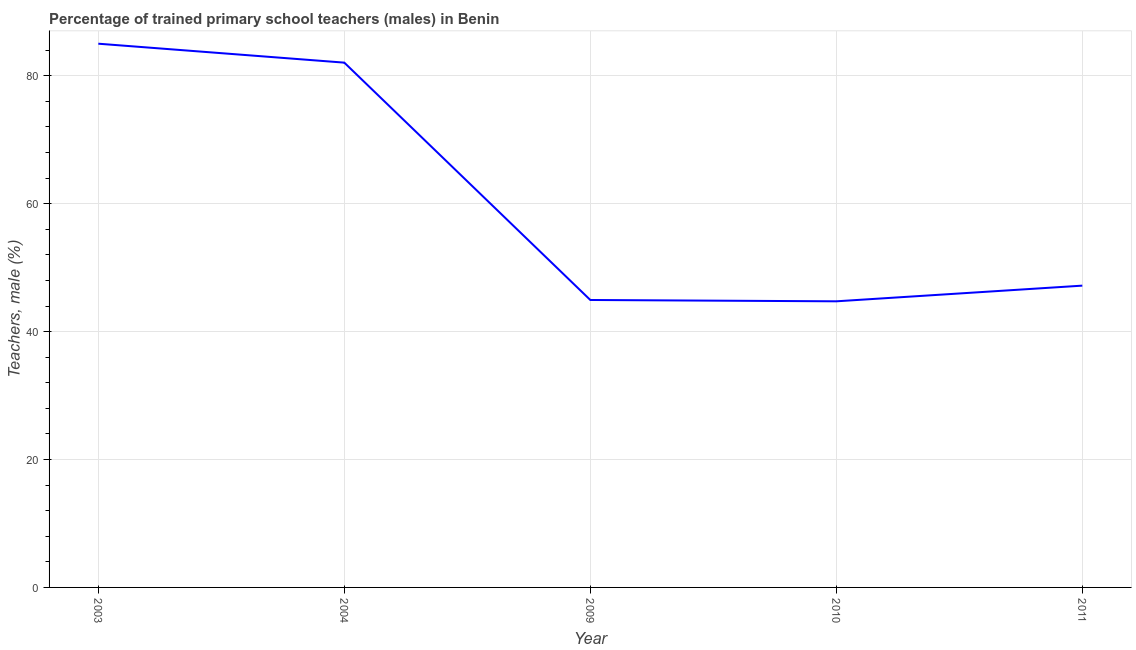What is the percentage of trained male teachers in 2011?
Keep it short and to the point. 47.19. Across all years, what is the maximum percentage of trained male teachers?
Make the answer very short. 85.01. Across all years, what is the minimum percentage of trained male teachers?
Your response must be concise. 44.74. In which year was the percentage of trained male teachers maximum?
Keep it short and to the point. 2003. In which year was the percentage of trained male teachers minimum?
Make the answer very short. 2010. What is the sum of the percentage of trained male teachers?
Ensure brevity in your answer.  303.93. What is the difference between the percentage of trained male teachers in 2004 and 2011?
Keep it short and to the point. 34.87. What is the average percentage of trained male teachers per year?
Offer a terse response. 60.79. What is the median percentage of trained male teachers?
Provide a succinct answer. 47.19. What is the ratio of the percentage of trained male teachers in 2010 to that in 2011?
Your answer should be compact. 0.95. What is the difference between the highest and the second highest percentage of trained male teachers?
Provide a short and direct response. 2.96. What is the difference between the highest and the lowest percentage of trained male teachers?
Provide a succinct answer. 40.28. In how many years, is the percentage of trained male teachers greater than the average percentage of trained male teachers taken over all years?
Offer a terse response. 2. How many lines are there?
Offer a terse response. 1. How many years are there in the graph?
Provide a succinct answer. 5. What is the difference between two consecutive major ticks on the Y-axis?
Provide a succinct answer. 20. Does the graph contain any zero values?
Make the answer very short. No. What is the title of the graph?
Your answer should be very brief. Percentage of trained primary school teachers (males) in Benin. What is the label or title of the X-axis?
Your response must be concise. Year. What is the label or title of the Y-axis?
Keep it short and to the point. Teachers, male (%). What is the Teachers, male (%) in 2003?
Provide a short and direct response. 85.01. What is the Teachers, male (%) in 2004?
Make the answer very short. 82.05. What is the Teachers, male (%) in 2009?
Your response must be concise. 44.94. What is the Teachers, male (%) in 2010?
Offer a very short reply. 44.74. What is the Teachers, male (%) in 2011?
Offer a very short reply. 47.19. What is the difference between the Teachers, male (%) in 2003 and 2004?
Keep it short and to the point. 2.96. What is the difference between the Teachers, male (%) in 2003 and 2009?
Keep it short and to the point. 40.07. What is the difference between the Teachers, male (%) in 2003 and 2010?
Give a very brief answer. 40.28. What is the difference between the Teachers, male (%) in 2003 and 2011?
Provide a short and direct response. 37.83. What is the difference between the Teachers, male (%) in 2004 and 2009?
Give a very brief answer. 37.11. What is the difference between the Teachers, male (%) in 2004 and 2010?
Your answer should be compact. 37.32. What is the difference between the Teachers, male (%) in 2004 and 2011?
Offer a terse response. 34.87. What is the difference between the Teachers, male (%) in 2009 and 2010?
Offer a very short reply. 0.21. What is the difference between the Teachers, male (%) in 2009 and 2011?
Keep it short and to the point. -2.24. What is the difference between the Teachers, male (%) in 2010 and 2011?
Your answer should be compact. -2.45. What is the ratio of the Teachers, male (%) in 2003 to that in 2004?
Your answer should be very brief. 1.04. What is the ratio of the Teachers, male (%) in 2003 to that in 2009?
Your answer should be compact. 1.89. What is the ratio of the Teachers, male (%) in 2003 to that in 2011?
Your response must be concise. 1.8. What is the ratio of the Teachers, male (%) in 2004 to that in 2009?
Give a very brief answer. 1.83. What is the ratio of the Teachers, male (%) in 2004 to that in 2010?
Offer a very short reply. 1.83. What is the ratio of the Teachers, male (%) in 2004 to that in 2011?
Provide a succinct answer. 1.74. What is the ratio of the Teachers, male (%) in 2009 to that in 2010?
Offer a terse response. 1. What is the ratio of the Teachers, male (%) in 2009 to that in 2011?
Offer a very short reply. 0.95. What is the ratio of the Teachers, male (%) in 2010 to that in 2011?
Keep it short and to the point. 0.95. 